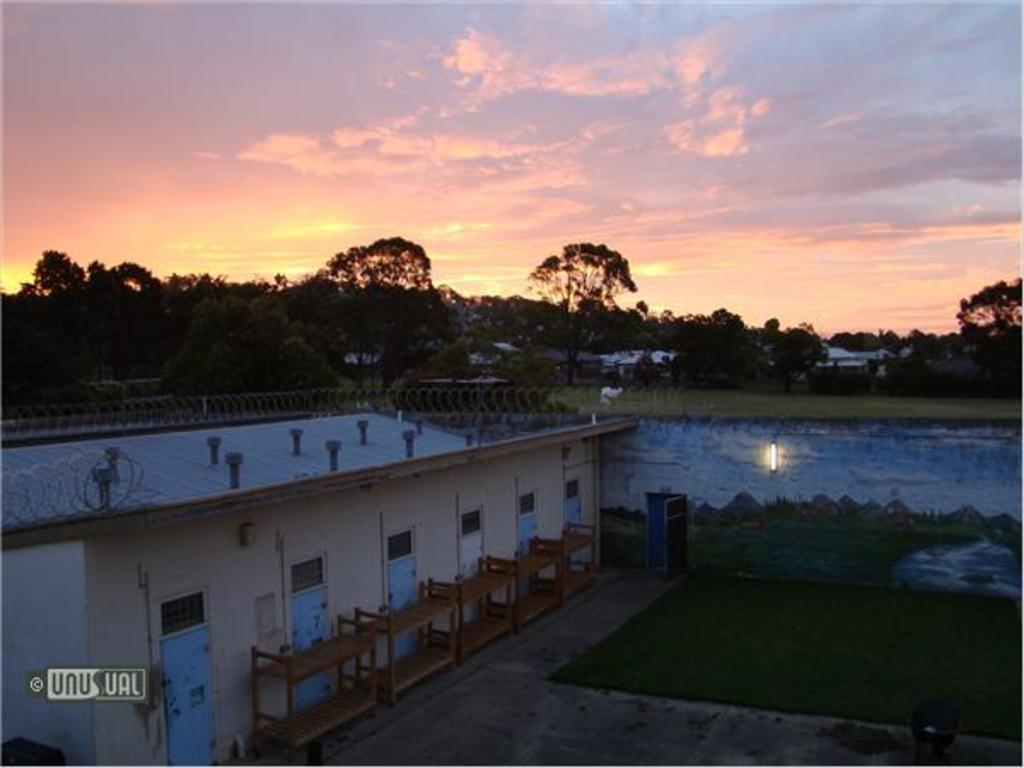What type of structures can be seen in the image? There are houses in the image. What type of furniture is present in the image? There are beds in the image. What type of vegetation is visible in the image? There are trees in the image. What type of architectural feature is present in the image? There are doors in the image. What type of natural element is visible in the image? There is water visible in the image. What type of ground cover is present in the image? There is grass in the image. What type of illumination is present in the image? There is light in the image. What type of background can be seen in the image? The sky is visible in the background of the image. What type of atmospheric feature is present in the sky? There are clouds in the sky. Can you tell me how many plants are growing on the board in the image? There is no board or plants present in the image. What type of toes can be seen in the image? There are no toes visible in the image. 